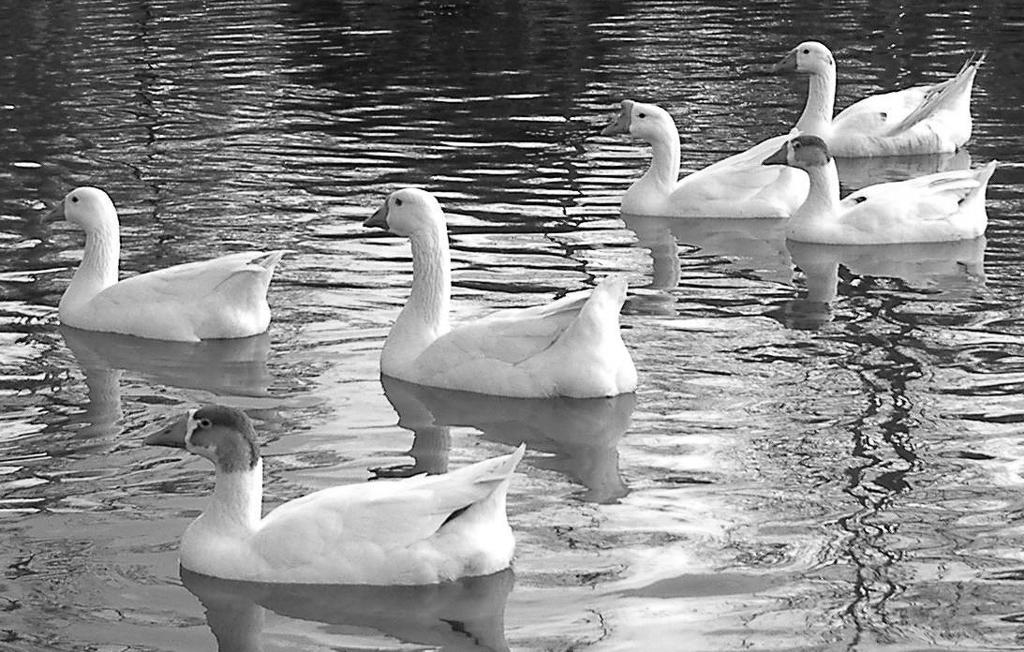Please provide a concise description of this image. In this image I can see the birds in the water. I can see this is a black and white image. 